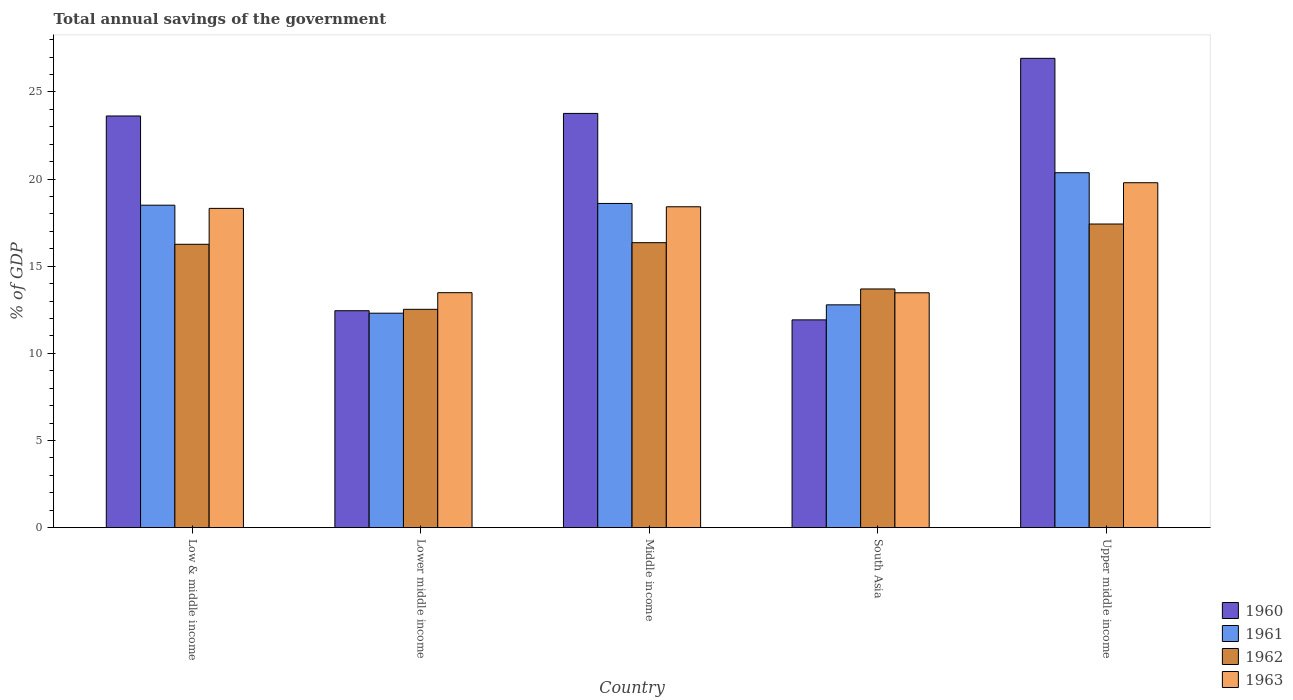Are the number of bars on each tick of the X-axis equal?
Give a very brief answer. Yes. How many bars are there on the 5th tick from the left?
Give a very brief answer. 4. How many bars are there on the 3rd tick from the right?
Your answer should be very brief. 4. What is the label of the 4th group of bars from the left?
Your answer should be compact. South Asia. What is the total annual savings of the government in 1963 in Middle income?
Offer a terse response. 18.41. Across all countries, what is the maximum total annual savings of the government in 1962?
Your answer should be compact. 17.42. Across all countries, what is the minimum total annual savings of the government in 1960?
Keep it short and to the point. 11.92. In which country was the total annual savings of the government in 1960 maximum?
Give a very brief answer. Upper middle income. In which country was the total annual savings of the government in 1962 minimum?
Provide a succinct answer. Lower middle income. What is the total total annual savings of the government in 1962 in the graph?
Give a very brief answer. 76.25. What is the difference between the total annual savings of the government in 1962 in Low & middle income and that in Upper middle income?
Ensure brevity in your answer.  -1.16. What is the difference between the total annual savings of the government in 1961 in South Asia and the total annual savings of the government in 1962 in Lower middle income?
Keep it short and to the point. 0.26. What is the average total annual savings of the government in 1962 per country?
Your answer should be compact. 15.25. What is the difference between the total annual savings of the government of/in 1961 and total annual savings of the government of/in 1963 in Low & middle income?
Give a very brief answer. 0.18. What is the ratio of the total annual savings of the government in 1962 in Lower middle income to that in South Asia?
Provide a short and direct response. 0.91. What is the difference between the highest and the second highest total annual savings of the government in 1960?
Keep it short and to the point. 3.31. What is the difference between the highest and the lowest total annual savings of the government in 1961?
Provide a short and direct response. 8.06. Is the sum of the total annual savings of the government in 1963 in Middle income and Upper middle income greater than the maximum total annual savings of the government in 1961 across all countries?
Provide a succinct answer. Yes. What does the 4th bar from the right in Lower middle income represents?
Your response must be concise. 1960. Is it the case that in every country, the sum of the total annual savings of the government in 1961 and total annual savings of the government in 1962 is greater than the total annual savings of the government in 1960?
Provide a succinct answer. Yes. How many countries are there in the graph?
Your response must be concise. 5. Are the values on the major ticks of Y-axis written in scientific E-notation?
Offer a terse response. No. Where does the legend appear in the graph?
Keep it short and to the point. Bottom right. How many legend labels are there?
Your answer should be compact. 4. How are the legend labels stacked?
Offer a terse response. Vertical. What is the title of the graph?
Offer a terse response. Total annual savings of the government. What is the label or title of the X-axis?
Your response must be concise. Country. What is the label or title of the Y-axis?
Ensure brevity in your answer.  % of GDP. What is the % of GDP in 1960 in Low & middle income?
Your answer should be compact. 23.62. What is the % of GDP of 1961 in Low & middle income?
Your answer should be compact. 18.5. What is the % of GDP in 1962 in Low & middle income?
Provide a short and direct response. 16.26. What is the % of GDP of 1963 in Low & middle income?
Your answer should be compact. 18.32. What is the % of GDP in 1960 in Lower middle income?
Offer a terse response. 12.45. What is the % of GDP of 1961 in Lower middle income?
Ensure brevity in your answer.  12.3. What is the % of GDP in 1962 in Lower middle income?
Make the answer very short. 12.53. What is the % of GDP in 1963 in Lower middle income?
Your response must be concise. 13.48. What is the % of GDP of 1960 in Middle income?
Your answer should be compact. 23.77. What is the % of GDP of 1961 in Middle income?
Offer a terse response. 18.6. What is the % of GDP in 1962 in Middle income?
Give a very brief answer. 16.35. What is the % of GDP of 1963 in Middle income?
Give a very brief answer. 18.41. What is the % of GDP in 1960 in South Asia?
Ensure brevity in your answer.  11.92. What is the % of GDP in 1961 in South Asia?
Keep it short and to the point. 12.78. What is the % of GDP in 1962 in South Asia?
Keep it short and to the point. 13.69. What is the % of GDP of 1963 in South Asia?
Offer a terse response. 13.48. What is the % of GDP in 1960 in Upper middle income?
Make the answer very short. 26.93. What is the % of GDP in 1961 in Upper middle income?
Your answer should be compact. 20.37. What is the % of GDP in 1962 in Upper middle income?
Your response must be concise. 17.42. What is the % of GDP of 1963 in Upper middle income?
Your answer should be very brief. 19.79. Across all countries, what is the maximum % of GDP in 1960?
Ensure brevity in your answer.  26.93. Across all countries, what is the maximum % of GDP in 1961?
Provide a succinct answer. 20.37. Across all countries, what is the maximum % of GDP in 1962?
Your answer should be compact. 17.42. Across all countries, what is the maximum % of GDP in 1963?
Offer a very short reply. 19.79. Across all countries, what is the minimum % of GDP in 1960?
Ensure brevity in your answer.  11.92. Across all countries, what is the minimum % of GDP of 1961?
Give a very brief answer. 12.3. Across all countries, what is the minimum % of GDP in 1962?
Your answer should be compact. 12.53. Across all countries, what is the minimum % of GDP in 1963?
Give a very brief answer. 13.48. What is the total % of GDP of 1960 in the graph?
Your answer should be compact. 98.69. What is the total % of GDP in 1961 in the graph?
Your answer should be compact. 82.56. What is the total % of GDP of 1962 in the graph?
Offer a very short reply. 76.25. What is the total % of GDP of 1963 in the graph?
Provide a succinct answer. 83.48. What is the difference between the % of GDP of 1960 in Low & middle income and that in Lower middle income?
Ensure brevity in your answer.  11.18. What is the difference between the % of GDP in 1961 in Low & middle income and that in Lower middle income?
Make the answer very short. 6.2. What is the difference between the % of GDP of 1962 in Low & middle income and that in Lower middle income?
Offer a very short reply. 3.73. What is the difference between the % of GDP of 1963 in Low & middle income and that in Lower middle income?
Provide a short and direct response. 4.84. What is the difference between the % of GDP of 1960 in Low & middle income and that in Middle income?
Your answer should be compact. -0.15. What is the difference between the % of GDP of 1961 in Low & middle income and that in Middle income?
Provide a short and direct response. -0.1. What is the difference between the % of GDP in 1962 in Low & middle income and that in Middle income?
Provide a succinct answer. -0.09. What is the difference between the % of GDP of 1963 in Low & middle income and that in Middle income?
Provide a short and direct response. -0.09. What is the difference between the % of GDP of 1960 in Low & middle income and that in South Asia?
Ensure brevity in your answer.  11.7. What is the difference between the % of GDP of 1961 in Low & middle income and that in South Asia?
Provide a short and direct response. 5.72. What is the difference between the % of GDP in 1962 in Low & middle income and that in South Asia?
Your answer should be very brief. 2.56. What is the difference between the % of GDP of 1963 in Low & middle income and that in South Asia?
Provide a succinct answer. 4.84. What is the difference between the % of GDP in 1960 in Low & middle income and that in Upper middle income?
Your answer should be very brief. -3.31. What is the difference between the % of GDP of 1961 in Low & middle income and that in Upper middle income?
Provide a short and direct response. -1.86. What is the difference between the % of GDP in 1962 in Low & middle income and that in Upper middle income?
Provide a short and direct response. -1.16. What is the difference between the % of GDP of 1963 in Low & middle income and that in Upper middle income?
Offer a very short reply. -1.47. What is the difference between the % of GDP in 1960 in Lower middle income and that in Middle income?
Your answer should be very brief. -11.32. What is the difference between the % of GDP in 1961 in Lower middle income and that in Middle income?
Offer a terse response. -6.3. What is the difference between the % of GDP in 1962 in Lower middle income and that in Middle income?
Keep it short and to the point. -3.82. What is the difference between the % of GDP in 1963 in Lower middle income and that in Middle income?
Keep it short and to the point. -4.93. What is the difference between the % of GDP in 1960 in Lower middle income and that in South Asia?
Ensure brevity in your answer.  0.52. What is the difference between the % of GDP in 1961 in Lower middle income and that in South Asia?
Give a very brief answer. -0.48. What is the difference between the % of GDP of 1962 in Lower middle income and that in South Asia?
Provide a succinct answer. -1.17. What is the difference between the % of GDP of 1963 in Lower middle income and that in South Asia?
Give a very brief answer. 0.01. What is the difference between the % of GDP in 1960 in Lower middle income and that in Upper middle income?
Your answer should be very brief. -14.48. What is the difference between the % of GDP of 1961 in Lower middle income and that in Upper middle income?
Provide a succinct answer. -8.06. What is the difference between the % of GDP in 1962 in Lower middle income and that in Upper middle income?
Ensure brevity in your answer.  -4.89. What is the difference between the % of GDP in 1963 in Lower middle income and that in Upper middle income?
Keep it short and to the point. -6.31. What is the difference between the % of GDP in 1960 in Middle income and that in South Asia?
Your response must be concise. 11.85. What is the difference between the % of GDP in 1961 in Middle income and that in South Asia?
Your response must be concise. 5.82. What is the difference between the % of GDP in 1962 in Middle income and that in South Asia?
Your response must be concise. 2.66. What is the difference between the % of GDP in 1963 in Middle income and that in South Asia?
Your answer should be compact. 4.94. What is the difference between the % of GDP of 1960 in Middle income and that in Upper middle income?
Your response must be concise. -3.16. What is the difference between the % of GDP of 1961 in Middle income and that in Upper middle income?
Keep it short and to the point. -1.76. What is the difference between the % of GDP of 1962 in Middle income and that in Upper middle income?
Provide a short and direct response. -1.07. What is the difference between the % of GDP of 1963 in Middle income and that in Upper middle income?
Give a very brief answer. -1.38. What is the difference between the % of GDP in 1960 in South Asia and that in Upper middle income?
Provide a succinct answer. -15.01. What is the difference between the % of GDP of 1961 in South Asia and that in Upper middle income?
Give a very brief answer. -7.58. What is the difference between the % of GDP of 1962 in South Asia and that in Upper middle income?
Your answer should be compact. -3.73. What is the difference between the % of GDP of 1963 in South Asia and that in Upper middle income?
Give a very brief answer. -6.32. What is the difference between the % of GDP of 1960 in Low & middle income and the % of GDP of 1961 in Lower middle income?
Keep it short and to the point. 11.32. What is the difference between the % of GDP in 1960 in Low & middle income and the % of GDP in 1962 in Lower middle income?
Give a very brief answer. 11.09. What is the difference between the % of GDP in 1960 in Low & middle income and the % of GDP in 1963 in Lower middle income?
Keep it short and to the point. 10.14. What is the difference between the % of GDP of 1961 in Low & middle income and the % of GDP of 1962 in Lower middle income?
Offer a very short reply. 5.97. What is the difference between the % of GDP of 1961 in Low & middle income and the % of GDP of 1963 in Lower middle income?
Your answer should be compact. 5.02. What is the difference between the % of GDP in 1962 in Low & middle income and the % of GDP in 1963 in Lower middle income?
Provide a short and direct response. 2.78. What is the difference between the % of GDP of 1960 in Low & middle income and the % of GDP of 1961 in Middle income?
Your answer should be very brief. 5.02. What is the difference between the % of GDP of 1960 in Low & middle income and the % of GDP of 1962 in Middle income?
Provide a short and direct response. 7.27. What is the difference between the % of GDP in 1960 in Low & middle income and the % of GDP in 1963 in Middle income?
Offer a terse response. 5.21. What is the difference between the % of GDP of 1961 in Low & middle income and the % of GDP of 1962 in Middle income?
Make the answer very short. 2.15. What is the difference between the % of GDP in 1961 in Low & middle income and the % of GDP in 1963 in Middle income?
Your answer should be very brief. 0.09. What is the difference between the % of GDP of 1962 in Low & middle income and the % of GDP of 1963 in Middle income?
Provide a short and direct response. -2.15. What is the difference between the % of GDP of 1960 in Low & middle income and the % of GDP of 1961 in South Asia?
Give a very brief answer. 10.84. What is the difference between the % of GDP in 1960 in Low & middle income and the % of GDP in 1962 in South Asia?
Provide a short and direct response. 9.93. What is the difference between the % of GDP in 1960 in Low & middle income and the % of GDP in 1963 in South Asia?
Offer a very short reply. 10.15. What is the difference between the % of GDP of 1961 in Low & middle income and the % of GDP of 1962 in South Asia?
Offer a very short reply. 4.81. What is the difference between the % of GDP of 1961 in Low & middle income and the % of GDP of 1963 in South Asia?
Make the answer very short. 5.03. What is the difference between the % of GDP of 1962 in Low & middle income and the % of GDP of 1963 in South Asia?
Provide a short and direct response. 2.78. What is the difference between the % of GDP in 1960 in Low & middle income and the % of GDP in 1961 in Upper middle income?
Provide a succinct answer. 3.26. What is the difference between the % of GDP in 1960 in Low & middle income and the % of GDP in 1962 in Upper middle income?
Provide a succinct answer. 6.2. What is the difference between the % of GDP of 1960 in Low & middle income and the % of GDP of 1963 in Upper middle income?
Offer a terse response. 3.83. What is the difference between the % of GDP in 1961 in Low & middle income and the % of GDP in 1962 in Upper middle income?
Give a very brief answer. 1.08. What is the difference between the % of GDP in 1961 in Low & middle income and the % of GDP in 1963 in Upper middle income?
Give a very brief answer. -1.29. What is the difference between the % of GDP in 1962 in Low & middle income and the % of GDP in 1963 in Upper middle income?
Ensure brevity in your answer.  -3.53. What is the difference between the % of GDP of 1960 in Lower middle income and the % of GDP of 1961 in Middle income?
Offer a terse response. -6.16. What is the difference between the % of GDP in 1960 in Lower middle income and the % of GDP in 1962 in Middle income?
Give a very brief answer. -3.9. What is the difference between the % of GDP of 1960 in Lower middle income and the % of GDP of 1963 in Middle income?
Provide a succinct answer. -5.97. What is the difference between the % of GDP of 1961 in Lower middle income and the % of GDP of 1962 in Middle income?
Your answer should be compact. -4.05. What is the difference between the % of GDP in 1961 in Lower middle income and the % of GDP in 1963 in Middle income?
Give a very brief answer. -6.11. What is the difference between the % of GDP in 1962 in Lower middle income and the % of GDP in 1963 in Middle income?
Keep it short and to the point. -5.88. What is the difference between the % of GDP in 1960 in Lower middle income and the % of GDP in 1961 in South Asia?
Offer a very short reply. -0.34. What is the difference between the % of GDP in 1960 in Lower middle income and the % of GDP in 1962 in South Asia?
Offer a terse response. -1.25. What is the difference between the % of GDP in 1960 in Lower middle income and the % of GDP in 1963 in South Asia?
Offer a very short reply. -1.03. What is the difference between the % of GDP of 1961 in Lower middle income and the % of GDP of 1962 in South Asia?
Make the answer very short. -1.39. What is the difference between the % of GDP of 1961 in Lower middle income and the % of GDP of 1963 in South Asia?
Your response must be concise. -1.17. What is the difference between the % of GDP of 1962 in Lower middle income and the % of GDP of 1963 in South Asia?
Ensure brevity in your answer.  -0.95. What is the difference between the % of GDP in 1960 in Lower middle income and the % of GDP in 1961 in Upper middle income?
Your response must be concise. -7.92. What is the difference between the % of GDP of 1960 in Lower middle income and the % of GDP of 1962 in Upper middle income?
Offer a terse response. -4.98. What is the difference between the % of GDP of 1960 in Lower middle income and the % of GDP of 1963 in Upper middle income?
Ensure brevity in your answer.  -7.35. What is the difference between the % of GDP of 1961 in Lower middle income and the % of GDP of 1962 in Upper middle income?
Offer a terse response. -5.12. What is the difference between the % of GDP in 1961 in Lower middle income and the % of GDP in 1963 in Upper middle income?
Offer a very short reply. -7.49. What is the difference between the % of GDP of 1962 in Lower middle income and the % of GDP of 1963 in Upper middle income?
Provide a succinct answer. -7.26. What is the difference between the % of GDP in 1960 in Middle income and the % of GDP in 1961 in South Asia?
Make the answer very short. 10.98. What is the difference between the % of GDP in 1960 in Middle income and the % of GDP in 1962 in South Asia?
Offer a very short reply. 10.07. What is the difference between the % of GDP of 1960 in Middle income and the % of GDP of 1963 in South Asia?
Offer a very short reply. 10.29. What is the difference between the % of GDP of 1961 in Middle income and the % of GDP of 1962 in South Asia?
Make the answer very short. 4.91. What is the difference between the % of GDP in 1961 in Middle income and the % of GDP in 1963 in South Asia?
Offer a very short reply. 5.13. What is the difference between the % of GDP in 1962 in Middle income and the % of GDP in 1963 in South Asia?
Offer a terse response. 2.88. What is the difference between the % of GDP in 1960 in Middle income and the % of GDP in 1961 in Upper middle income?
Ensure brevity in your answer.  3.4. What is the difference between the % of GDP of 1960 in Middle income and the % of GDP of 1962 in Upper middle income?
Your answer should be very brief. 6.35. What is the difference between the % of GDP of 1960 in Middle income and the % of GDP of 1963 in Upper middle income?
Give a very brief answer. 3.98. What is the difference between the % of GDP of 1961 in Middle income and the % of GDP of 1962 in Upper middle income?
Make the answer very short. 1.18. What is the difference between the % of GDP of 1961 in Middle income and the % of GDP of 1963 in Upper middle income?
Your response must be concise. -1.19. What is the difference between the % of GDP of 1962 in Middle income and the % of GDP of 1963 in Upper middle income?
Your response must be concise. -3.44. What is the difference between the % of GDP in 1960 in South Asia and the % of GDP in 1961 in Upper middle income?
Offer a terse response. -8.44. What is the difference between the % of GDP of 1960 in South Asia and the % of GDP of 1962 in Upper middle income?
Offer a terse response. -5.5. What is the difference between the % of GDP of 1960 in South Asia and the % of GDP of 1963 in Upper middle income?
Give a very brief answer. -7.87. What is the difference between the % of GDP in 1961 in South Asia and the % of GDP in 1962 in Upper middle income?
Provide a succinct answer. -4.64. What is the difference between the % of GDP of 1961 in South Asia and the % of GDP of 1963 in Upper middle income?
Offer a very short reply. -7.01. What is the difference between the % of GDP of 1962 in South Asia and the % of GDP of 1963 in Upper middle income?
Your answer should be compact. -6.1. What is the average % of GDP of 1960 per country?
Your response must be concise. 19.74. What is the average % of GDP of 1961 per country?
Ensure brevity in your answer.  16.51. What is the average % of GDP in 1962 per country?
Keep it short and to the point. 15.25. What is the average % of GDP of 1963 per country?
Ensure brevity in your answer.  16.7. What is the difference between the % of GDP of 1960 and % of GDP of 1961 in Low & middle income?
Provide a short and direct response. 5.12. What is the difference between the % of GDP of 1960 and % of GDP of 1962 in Low & middle income?
Give a very brief answer. 7.36. What is the difference between the % of GDP in 1960 and % of GDP in 1963 in Low & middle income?
Your response must be concise. 5.3. What is the difference between the % of GDP in 1961 and % of GDP in 1962 in Low & middle income?
Provide a short and direct response. 2.24. What is the difference between the % of GDP in 1961 and % of GDP in 1963 in Low & middle income?
Your answer should be very brief. 0.18. What is the difference between the % of GDP of 1962 and % of GDP of 1963 in Low & middle income?
Your response must be concise. -2.06. What is the difference between the % of GDP in 1960 and % of GDP in 1961 in Lower middle income?
Offer a terse response. 0.14. What is the difference between the % of GDP in 1960 and % of GDP in 1962 in Lower middle income?
Offer a terse response. -0.08. What is the difference between the % of GDP in 1960 and % of GDP in 1963 in Lower middle income?
Offer a very short reply. -1.04. What is the difference between the % of GDP in 1961 and % of GDP in 1962 in Lower middle income?
Your response must be concise. -0.22. What is the difference between the % of GDP in 1961 and % of GDP in 1963 in Lower middle income?
Provide a short and direct response. -1.18. What is the difference between the % of GDP of 1962 and % of GDP of 1963 in Lower middle income?
Keep it short and to the point. -0.95. What is the difference between the % of GDP of 1960 and % of GDP of 1961 in Middle income?
Provide a short and direct response. 5.17. What is the difference between the % of GDP in 1960 and % of GDP in 1962 in Middle income?
Offer a very short reply. 7.42. What is the difference between the % of GDP in 1960 and % of GDP in 1963 in Middle income?
Ensure brevity in your answer.  5.36. What is the difference between the % of GDP of 1961 and % of GDP of 1962 in Middle income?
Make the answer very short. 2.25. What is the difference between the % of GDP of 1961 and % of GDP of 1963 in Middle income?
Provide a succinct answer. 0.19. What is the difference between the % of GDP of 1962 and % of GDP of 1963 in Middle income?
Provide a succinct answer. -2.06. What is the difference between the % of GDP of 1960 and % of GDP of 1961 in South Asia?
Offer a terse response. -0.86. What is the difference between the % of GDP of 1960 and % of GDP of 1962 in South Asia?
Make the answer very short. -1.77. What is the difference between the % of GDP of 1960 and % of GDP of 1963 in South Asia?
Provide a succinct answer. -1.55. What is the difference between the % of GDP in 1961 and % of GDP in 1962 in South Asia?
Keep it short and to the point. -0.91. What is the difference between the % of GDP in 1961 and % of GDP in 1963 in South Asia?
Keep it short and to the point. -0.69. What is the difference between the % of GDP of 1962 and % of GDP of 1963 in South Asia?
Offer a terse response. 0.22. What is the difference between the % of GDP in 1960 and % of GDP in 1961 in Upper middle income?
Keep it short and to the point. 6.56. What is the difference between the % of GDP of 1960 and % of GDP of 1962 in Upper middle income?
Your response must be concise. 9.51. What is the difference between the % of GDP of 1960 and % of GDP of 1963 in Upper middle income?
Offer a very short reply. 7.14. What is the difference between the % of GDP of 1961 and % of GDP of 1962 in Upper middle income?
Make the answer very short. 2.94. What is the difference between the % of GDP of 1961 and % of GDP of 1963 in Upper middle income?
Provide a short and direct response. 0.57. What is the difference between the % of GDP in 1962 and % of GDP in 1963 in Upper middle income?
Your answer should be compact. -2.37. What is the ratio of the % of GDP in 1960 in Low & middle income to that in Lower middle income?
Give a very brief answer. 1.9. What is the ratio of the % of GDP in 1961 in Low & middle income to that in Lower middle income?
Your answer should be compact. 1.5. What is the ratio of the % of GDP in 1962 in Low & middle income to that in Lower middle income?
Offer a terse response. 1.3. What is the ratio of the % of GDP in 1963 in Low & middle income to that in Lower middle income?
Provide a succinct answer. 1.36. What is the ratio of the % of GDP of 1961 in Low & middle income to that in Middle income?
Your answer should be very brief. 0.99. What is the ratio of the % of GDP in 1962 in Low & middle income to that in Middle income?
Give a very brief answer. 0.99. What is the ratio of the % of GDP of 1960 in Low & middle income to that in South Asia?
Your response must be concise. 1.98. What is the ratio of the % of GDP in 1961 in Low & middle income to that in South Asia?
Offer a terse response. 1.45. What is the ratio of the % of GDP in 1962 in Low & middle income to that in South Asia?
Provide a succinct answer. 1.19. What is the ratio of the % of GDP of 1963 in Low & middle income to that in South Asia?
Offer a terse response. 1.36. What is the ratio of the % of GDP in 1960 in Low & middle income to that in Upper middle income?
Keep it short and to the point. 0.88. What is the ratio of the % of GDP in 1961 in Low & middle income to that in Upper middle income?
Offer a very short reply. 0.91. What is the ratio of the % of GDP in 1962 in Low & middle income to that in Upper middle income?
Keep it short and to the point. 0.93. What is the ratio of the % of GDP of 1963 in Low & middle income to that in Upper middle income?
Give a very brief answer. 0.93. What is the ratio of the % of GDP in 1960 in Lower middle income to that in Middle income?
Your answer should be very brief. 0.52. What is the ratio of the % of GDP of 1961 in Lower middle income to that in Middle income?
Make the answer very short. 0.66. What is the ratio of the % of GDP of 1962 in Lower middle income to that in Middle income?
Your answer should be very brief. 0.77. What is the ratio of the % of GDP in 1963 in Lower middle income to that in Middle income?
Offer a very short reply. 0.73. What is the ratio of the % of GDP in 1960 in Lower middle income to that in South Asia?
Make the answer very short. 1.04. What is the ratio of the % of GDP in 1961 in Lower middle income to that in South Asia?
Provide a short and direct response. 0.96. What is the ratio of the % of GDP of 1962 in Lower middle income to that in South Asia?
Give a very brief answer. 0.91. What is the ratio of the % of GDP in 1963 in Lower middle income to that in South Asia?
Make the answer very short. 1. What is the ratio of the % of GDP of 1960 in Lower middle income to that in Upper middle income?
Ensure brevity in your answer.  0.46. What is the ratio of the % of GDP in 1961 in Lower middle income to that in Upper middle income?
Provide a short and direct response. 0.6. What is the ratio of the % of GDP in 1962 in Lower middle income to that in Upper middle income?
Give a very brief answer. 0.72. What is the ratio of the % of GDP in 1963 in Lower middle income to that in Upper middle income?
Make the answer very short. 0.68. What is the ratio of the % of GDP in 1960 in Middle income to that in South Asia?
Make the answer very short. 1.99. What is the ratio of the % of GDP of 1961 in Middle income to that in South Asia?
Your response must be concise. 1.46. What is the ratio of the % of GDP in 1962 in Middle income to that in South Asia?
Keep it short and to the point. 1.19. What is the ratio of the % of GDP of 1963 in Middle income to that in South Asia?
Your answer should be compact. 1.37. What is the ratio of the % of GDP in 1960 in Middle income to that in Upper middle income?
Your response must be concise. 0.88. What is the ratio of the % of GDP of 1961 in Middle income to that in Upper middle income?
Your answer should be compact. 0.91. What is the ratio of the % of GDP in 1962 in Middle income to that in Upper middle income?
Make the answer very short. 0.94. What is the ratio of the % of GDP in 1963 in Middle income to that in Upper middle income?
Your answer should be compact. 0.93. What is the ratio of the % of GDP in 1960 in South Asia to that in Upper middle income?
Your answer should be very brief. 0.44. What is the ratio of the % of GDP of 1961 in South Asia to that in Upper middle income?
Ensure brevity in your answer.  0.63. What is the ratio of the % of GDP of 1962 in South Asia to that in Upper middle income?
Ensure brevity in your answer.  0.79. What is the ratio of the % of GDP of 1963 in South Asia to that in Upper middle income?
Provide a short and direct response. 0.68. What is the difference between the highest and the second highest % of GDP in 1960?
Keep it short and to the point. 3.16. What is the difference between the highest and the second highest % of GDP of 1961?
Your answer should be very brief. 1.76. What is the difference between the highest and the second highest % of GDP of 1962?
Keep it short and to the point. 1.07. What is the difference between the highest and the second highest % of GDP of 1963?
Ensure brevity in your answer.  1.38. What is the difference between the highest and the lowest % of GDP of 1960?
Provide a short and direct response. 15.01. What is the difference between the highest and the lowest % of GDP of 1961?
Your answer should be very brief. 8.06. What is the difference between the highest and the lowest % of GDP of 1962?
Make the answer very short. 4.89. What is the difference between the highest and the lowest % of GDP of 1963?
Your response must be concise. 6.32. 